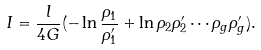Convert formula to latex. <formula><loc_0><loc_0><loc_500><loc_500>I = \frac { l } { 4 G } ( - \ln \frac { \rho _ { 1 } } { \rho _ { 1 } ^ { \prime } } + \ln \rho _ { 2 } \rho _ { 2 } ^ { \prime } \cdots \rho _ { g } \rho _ { g } ^ { \prime } ) .</formula> 